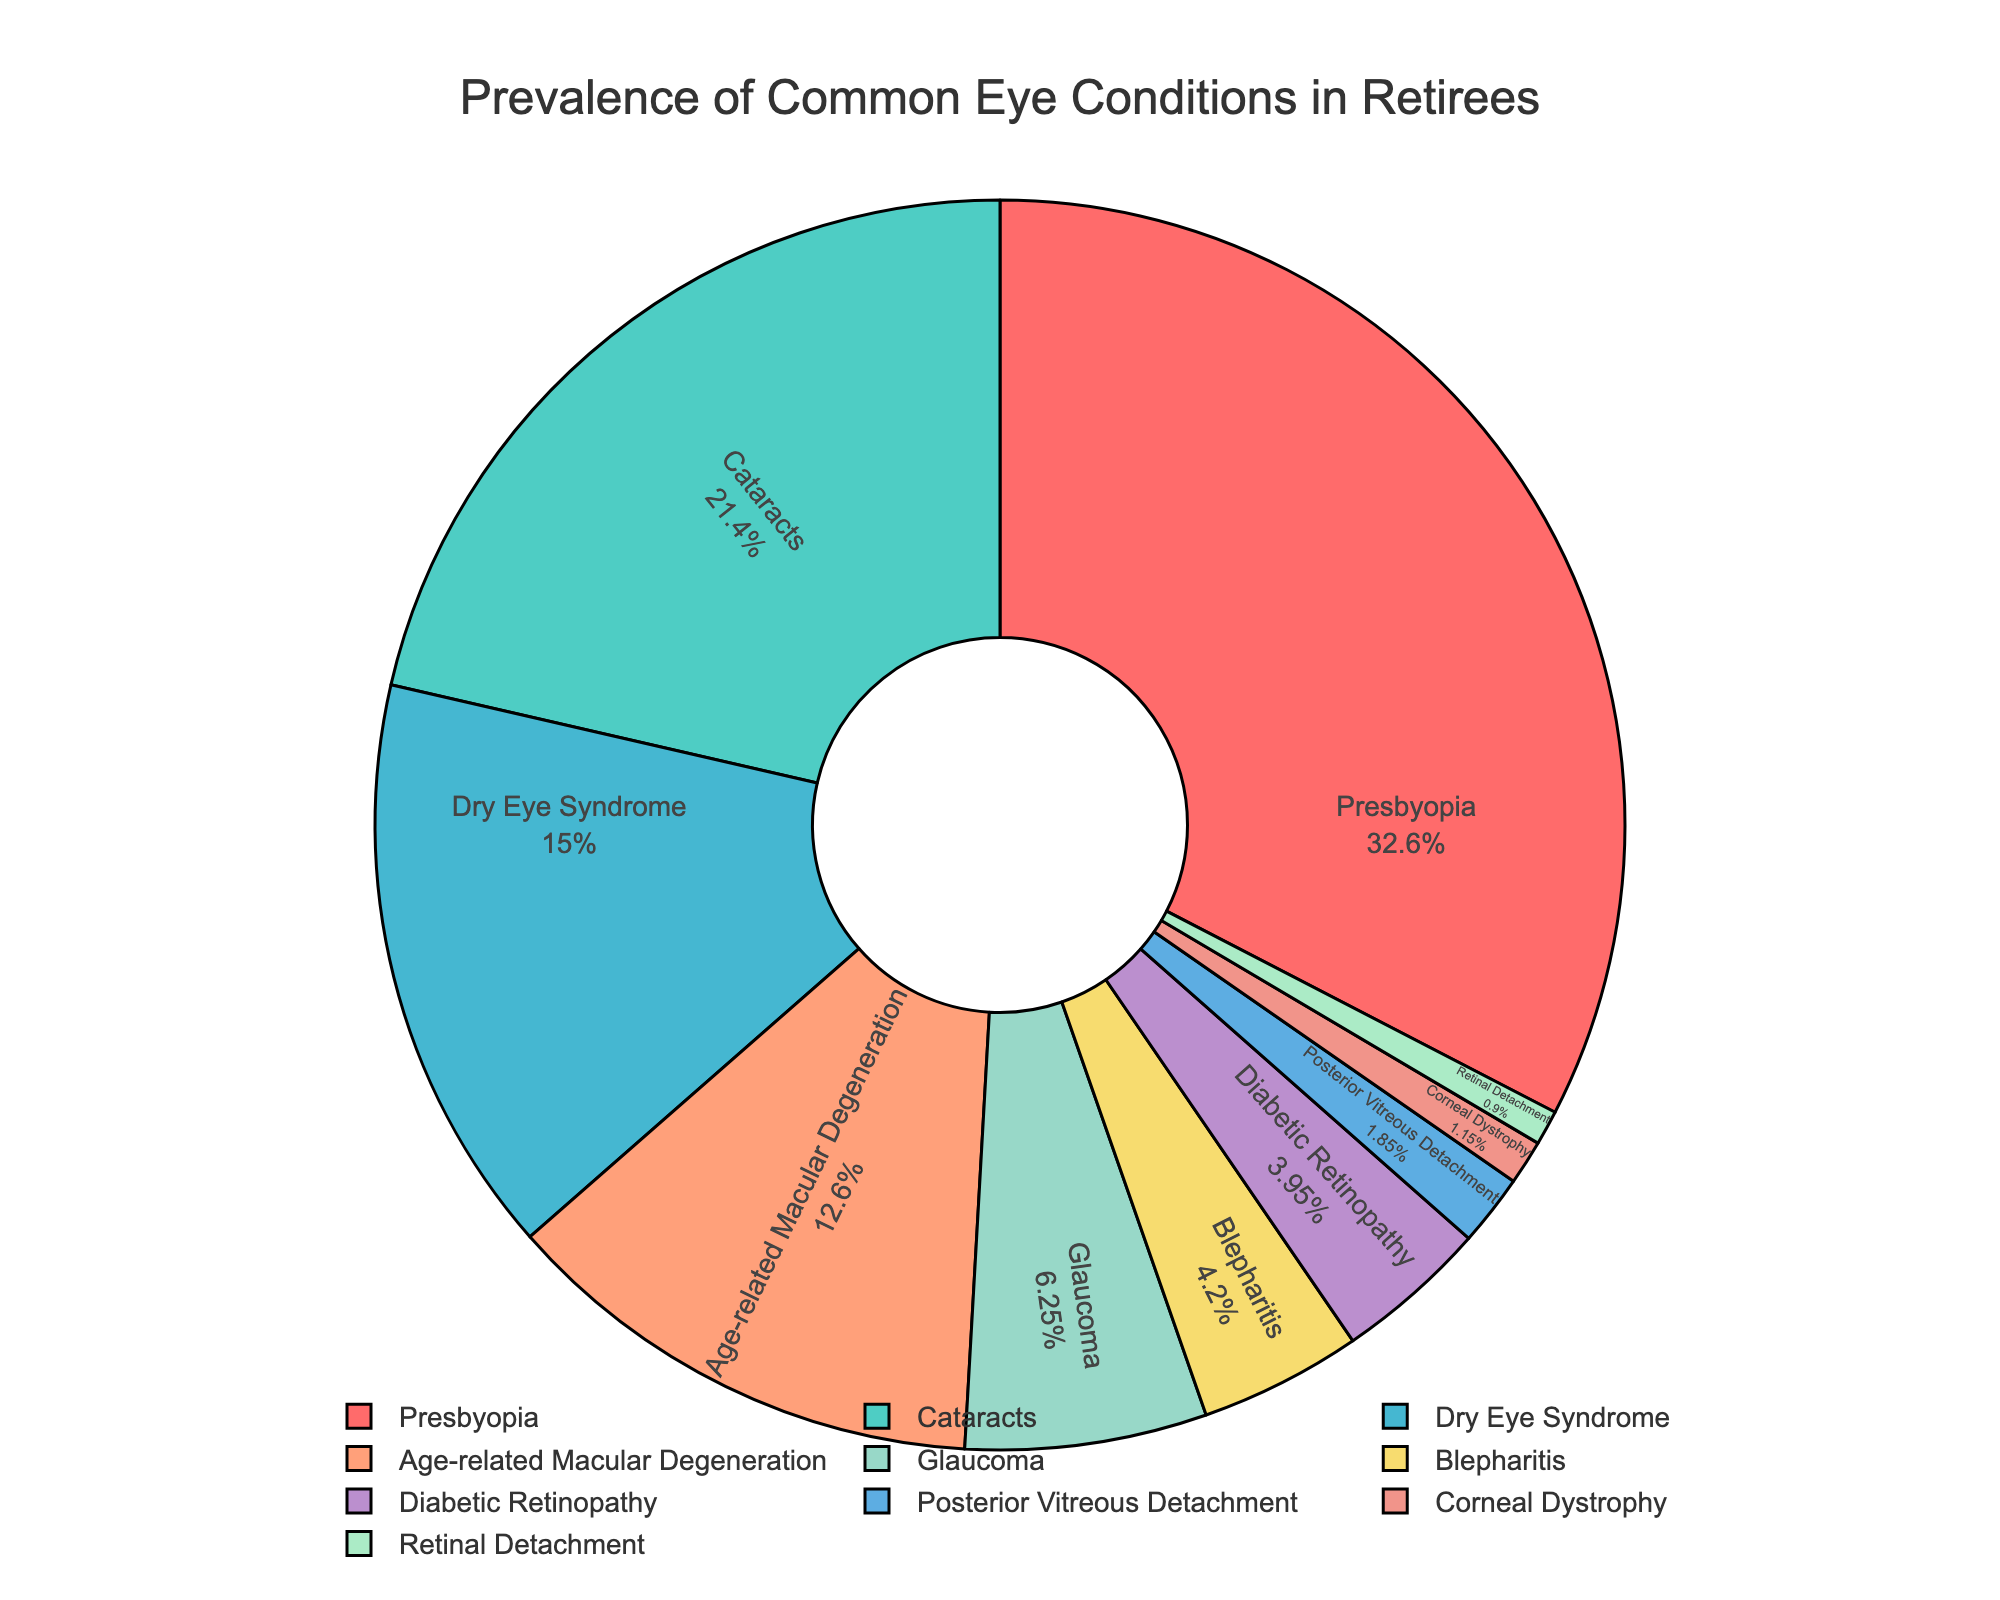What is the most common eye condition among retirees according to the figure? The figure provides prevalence percentages of various eye conditions among retirees. The largest segment of the pie chart, representing 65.2%, is labeled as Presbyopia. Therefore, Presbyopia is the most common eye condition.
Answer: Presbyopia Which eye condition has a higher prevalence: Cataracts or Dry Eye Syndrome? Comparing the segments of the pie chart, the condition Cataracts has a prevalence of 42.8%, and Dry Eye Syndrome has a prevalence of 30.1%. Since 42.8% is greater than 30.1%, Cataracts have a higher prevalence.
Answer: Cataracts What is the combined prevalence of Glaucoma, Diabetic Retinopathy, and Blepharitis? To find the combined prevalence, sum the individual prevalences: Glaucoma (12.5%) + Diabetic Retinopathy (7.9%) + Blepharitis (8.4%). Calculating their total: 12.5 + 7.9 + 8.4 = 28.8%.
Answer: 28.8% How does the prevalence of Age-related Macular Degeneration compare to that of Posterior Vitreous Detachment? Age-related Macular Degeneration has a prevalence of 25.3%, while Posterior Vitreous Detachment has a prevalence of 3.7%. Since 25.3% is much higher than 3.7%, Age-related Macular Degeneration is more prevalent.
Answer: Age-related Macular Degeneration Which eye condition is represented by the green segment in the pie chart? Observing the colors in the pie chart, the green segment corresponds to Presbyopia. This is because Presbyopia has a high prevalence (65.2%) making it easier to identify the green segment being the largest.
Answer: Presbyopia What is the least common eye condition among retirees according to the figure? The smallest segment in the pie chart, with a prevalence of 1.8%, is labeled as Retinal Detachment. Hence, Retinal Detachment is the least common eye condition.
Answer: Retinal Detachment 